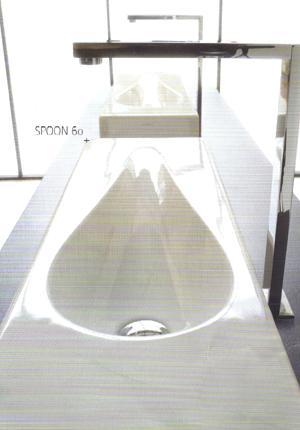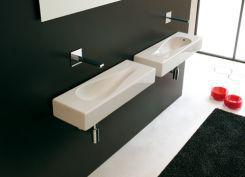The first image is the image on the left, the second image is the image on the right. Assess this claim about the two images: "In one image, two rectangular sinks with chrome faucet fixture are positioned side by side.". Correct or not? Answer yes or no. Yes. The first image is the image on the left, the second image is the image on the right. Assess this claim about the two images: "The right image features two tear-drop carved white sinks positioned side-by-side.". Correct or not? Answer yes or no. Yes. 